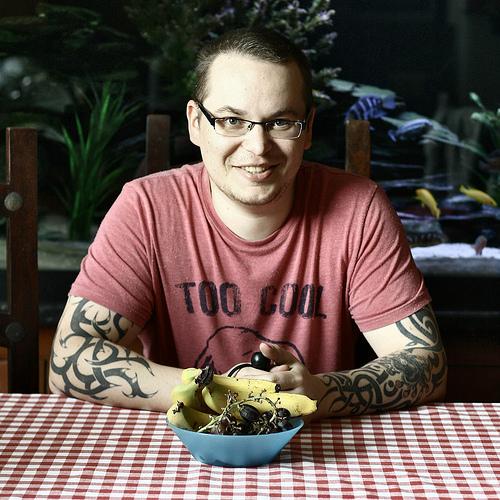Are those real tattoos?
Concise answer only. Yes. Is the man preparing a sandwich?
Write a very short answer. No. What fruit is shown?
Write a very short answer. Banana. What does his shirt say?
Short answer required. Too cool. 